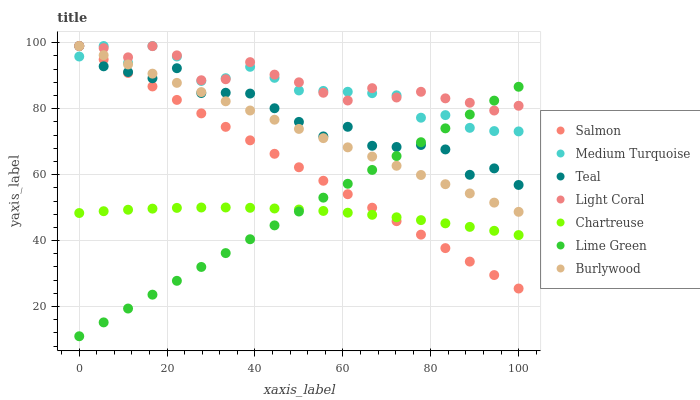Does Chartreuse have the minimum area under the curve?
Answer yes or no. Yes. Does Light Coral have the maximum area under the curve?
Answer yes or no. Yes. Does Burlywood have the minimum area under the curve?
Answer yes or no. No. Does Burlywood have the maximum area under the curve?
Answer yes or no. No. Is Lime Green the smoothest?
Answer yes or no. Yes. Is Teal the roughest?
Answer yes or no. Yes. Is Burlywood the smoothest?
Answer yes or no. No. Is Burlywood the roughest?
Answer yes or no. No. Does Lime Green have the lowest value?
Answer yes or no. Yes. Does Burlywood have the lowest value?
Answer yes or no. No. Does Teal have the highest value?
Answer yes or no. Yes. Does Chartreuse have the highest value?
Answer yes or no. No. Is Chartreuse less than Teal?
Answer yes or no. Yes. Is Teal greater than Chartreuse?
Answer yes or no. Yes. Does Lime Green intersect Burlywood?
Answer yes or no. Yes. Is Lime Green less than Burlywood?
Answer yes or no. No. Is Lime Green greater than Burlywood?
Answer yes or no. No. Does Chartreuse intersect Teal?
Answer yes or no. No. 